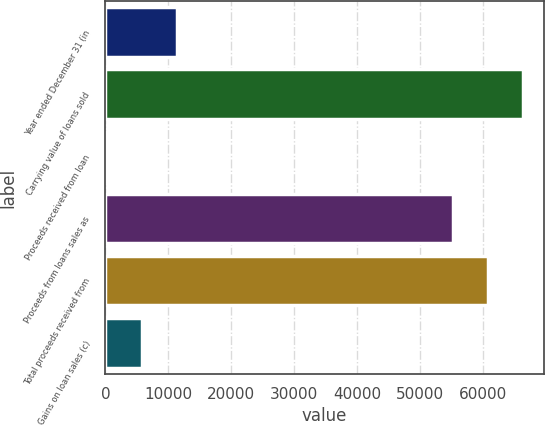<chart> <loc_0><loc_0><loc_500><loc_500><bar_chart><fcel>Year ended December 31 (in<fcel>Carrying value of loans sold<fcel>Proceeds received from loan<fcel>Proceeds from loans sales as<fcel>Total proceeds received from<fcel>Gains on loan sales (c)<nl><fcel>11368.4<fcel>66225.4<fcel>260<fcel>55117<fcel>60671.2<fcel>5814.2<nl></chart> 